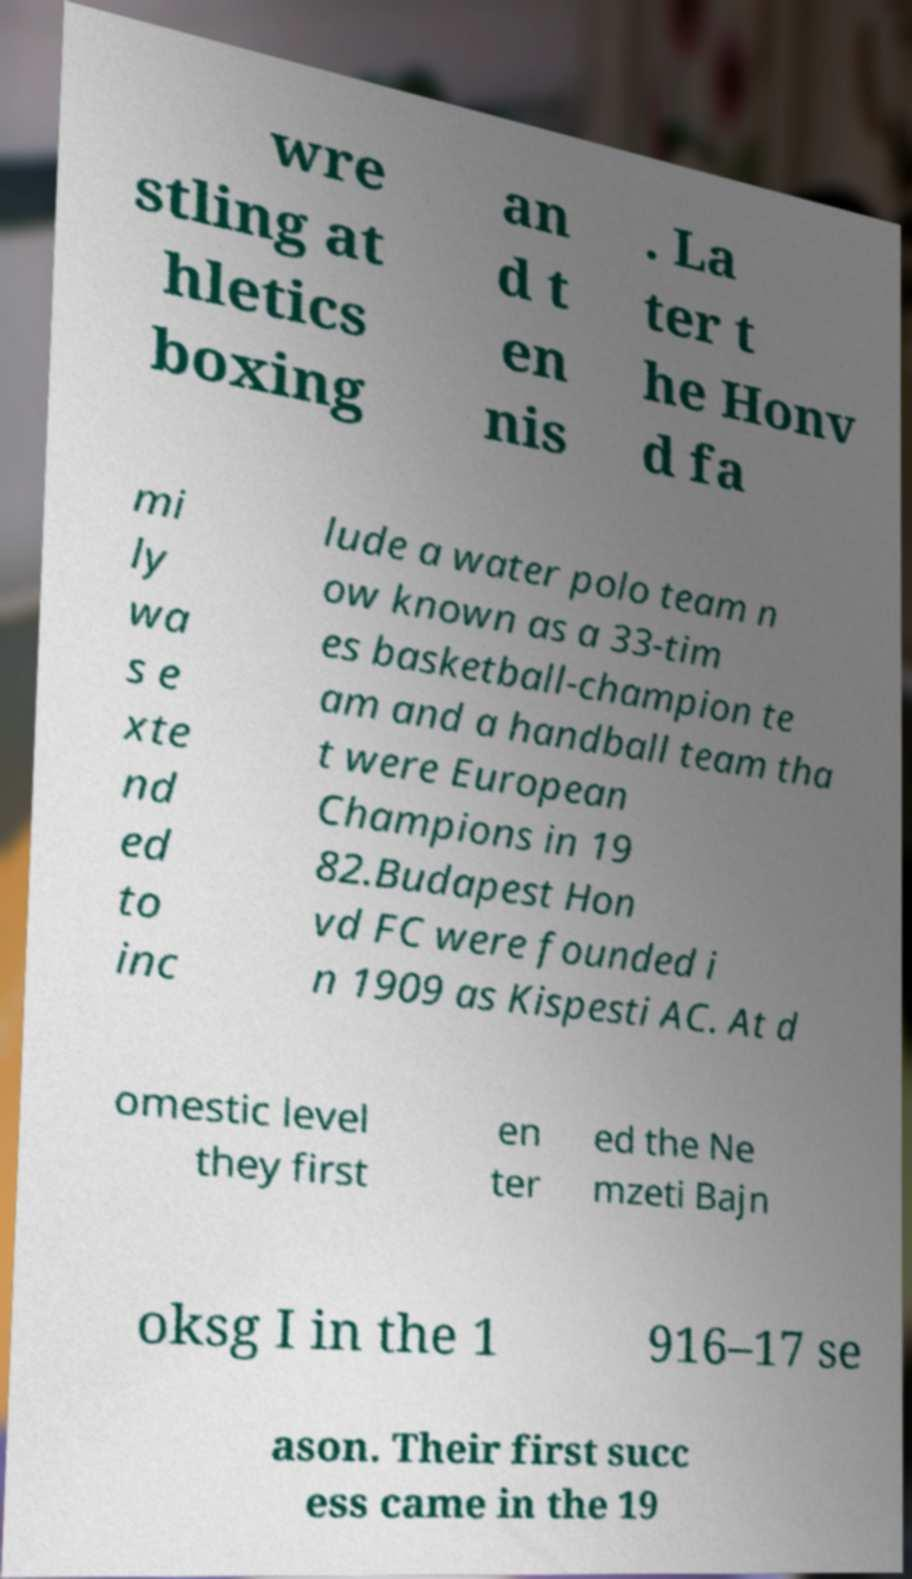Could you extract and type out the text from this image? wre stling at hletics boxing an d t en nis . La ter t he Honv d fa mi ly wa s e xte nd ed to inc lude a water polo team n ow known as a 33-tim es basketball-champion te am and a handball team tha t were European Champions in 19 82.Budapest Hon vd FC were founded i n 1909 as Kispesti AC. At d omestic level they first en ter ed the Ne mzeti Bajn oksg I in the 1 916–17 se ason. Their first succ ess came in the 19 